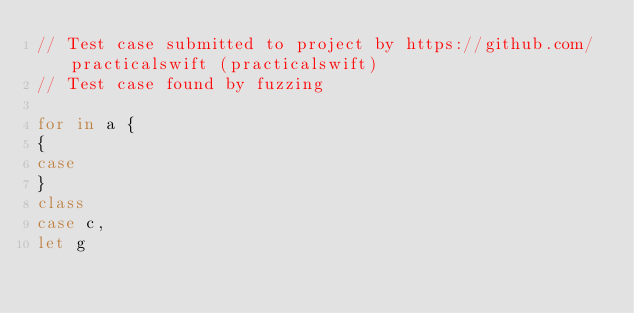Convert code to text. <code><loc_0><loc_0><loc_500><loc_500><_Swift_>// Test case submitted to project by https://github.com/practicalswift (practicalswift)
// Test case found by fuzzing

for in a {
{
case
}
class
case c,
let g
</code> 